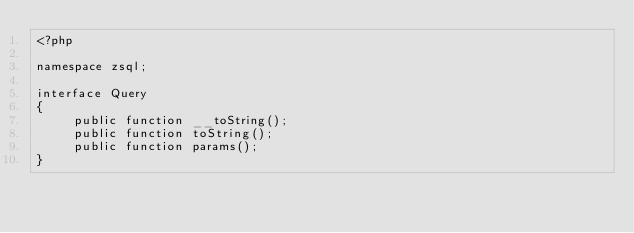Convert code to text. <code><loc_0><loc_0><loc_500><loc_500><_PHP_><?php

namespace zsql;

interface Query
{
     public function __toString();
     public function toString();
     public function params();
}
</code> 